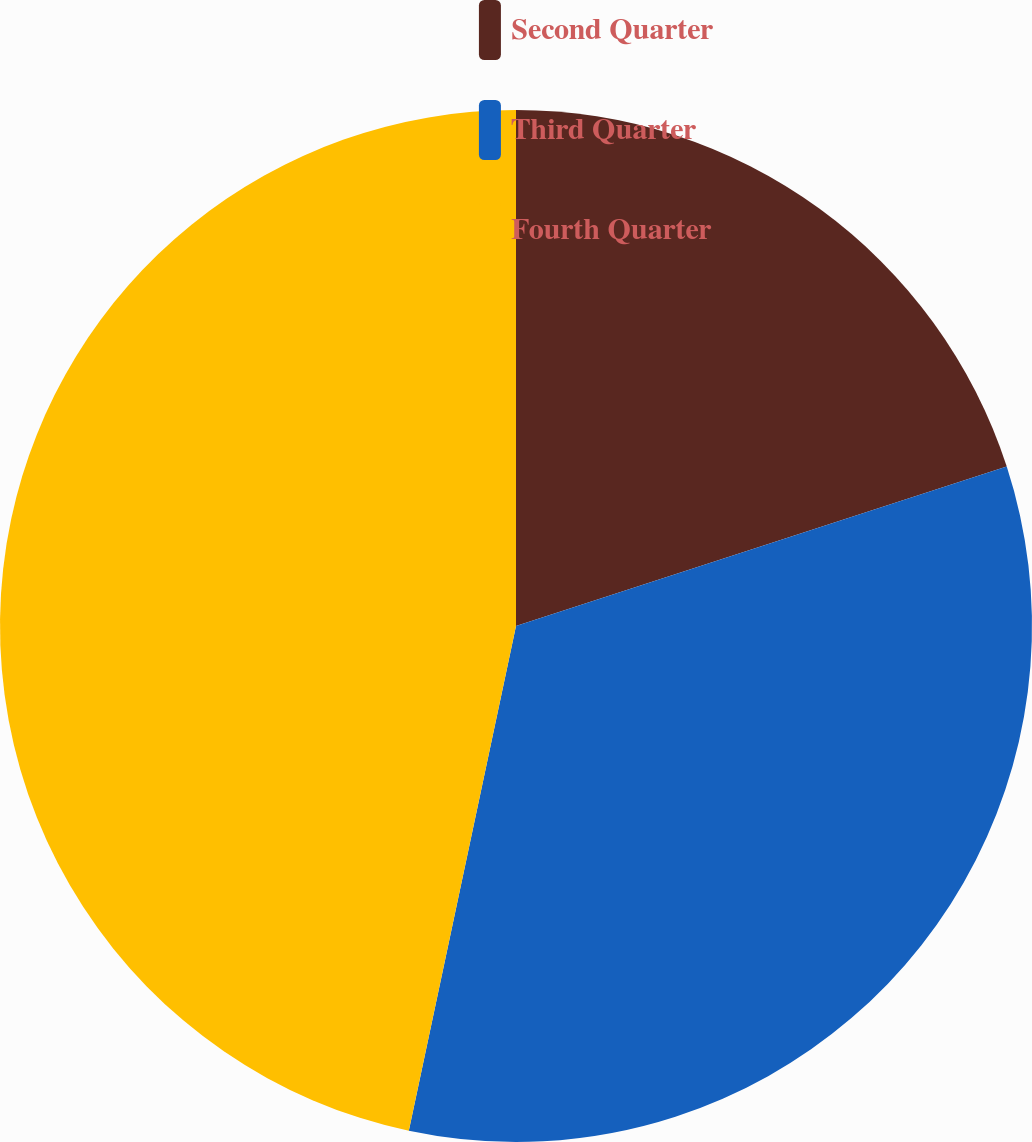Convert chart. <chart><loc_0><loc_0><loc_500><loc_500><pie_chart><fcel>Second Quarter<fcel>Third Quarter<fcel>Fourth Quarter<nl><fcel>20.0%<fcel>33.33%<fcel>46.67%<nl></chart> 